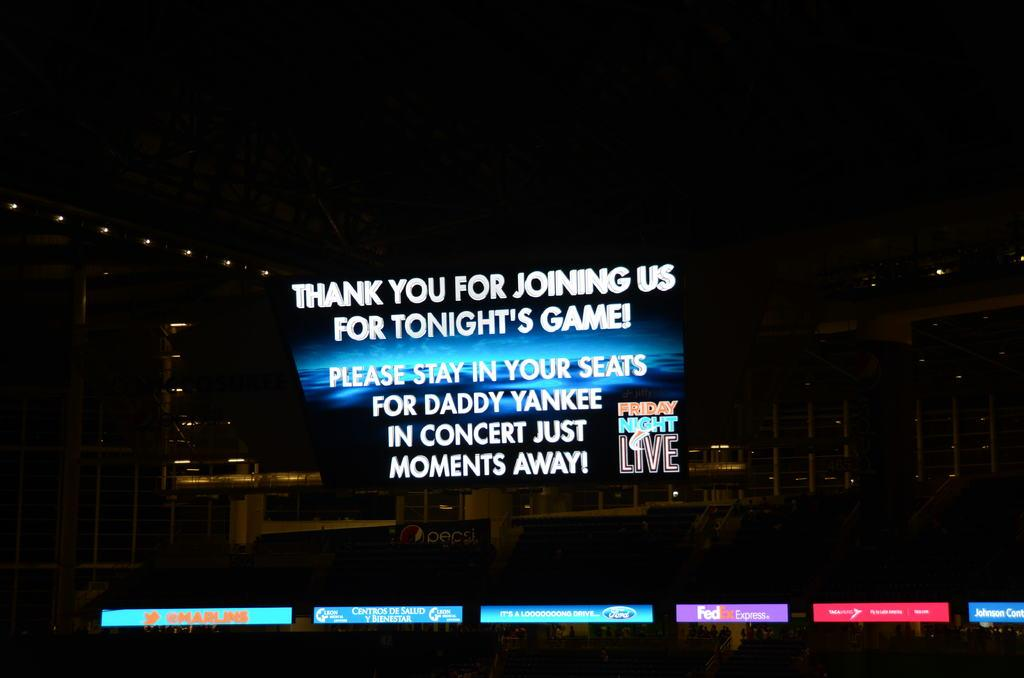<image>
Relay a brief, clear account of the picture shown. A sign announces an upcoming Daddy Yankee concert. 